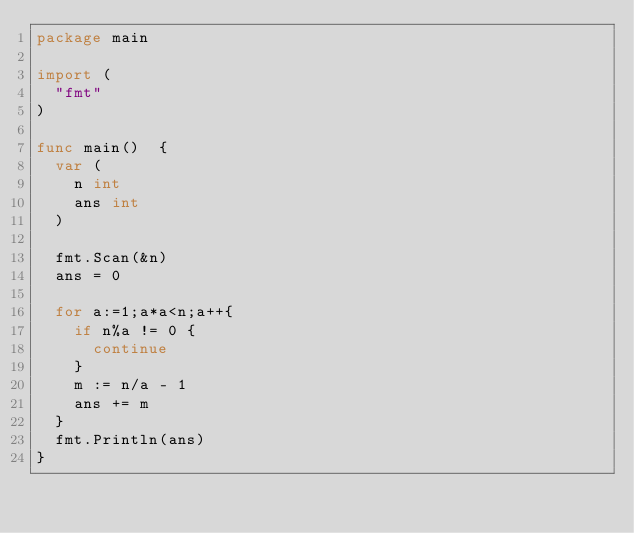Convert code to text. <code><loc_0><loc_0><loc_500><loc_500><_Go_>package main

import (
  "fmt"
)

func main()  {
  var (
    n int
    ans int
  )

  fmt.Scan(&n)
  ans = 0

  for a:=1;a*a<n;a++{
    if n%a != 0 {
      continue
    }
    m := n/a - 1
    ans += m
  }
  fmt.Println(ans)
}
</code> 